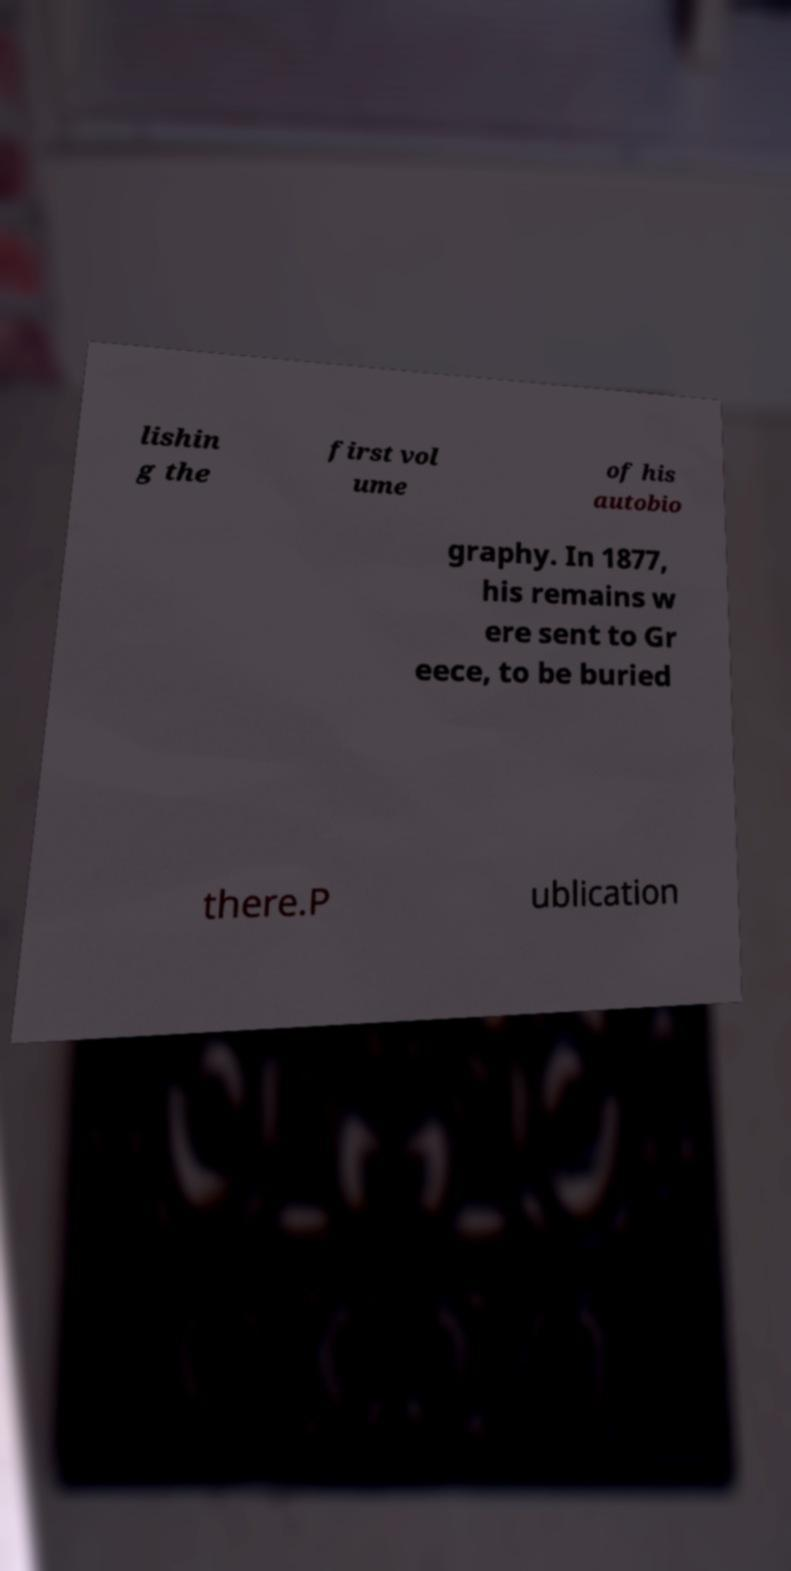Could you extract and type out the text from this image? lishin g the first vol ume of his autobio graphy. In 1877, his remains w ere sent to Gr eece, to be buried there.P ublication 